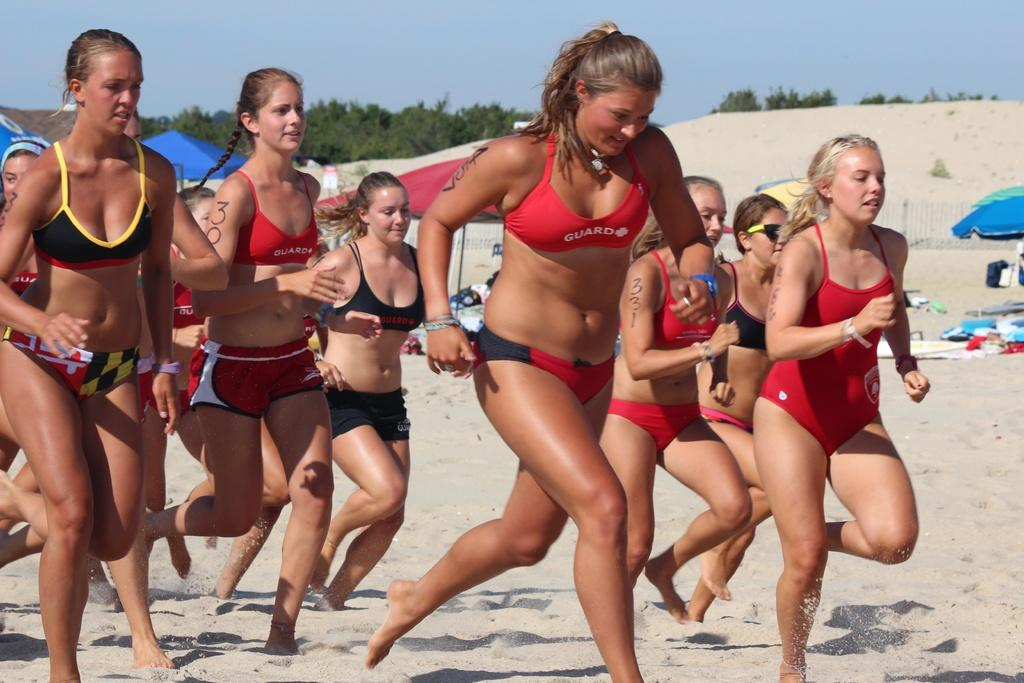Provide a one-sentence caption for the provided image. A girl with a bikini on that says Guard on it. 